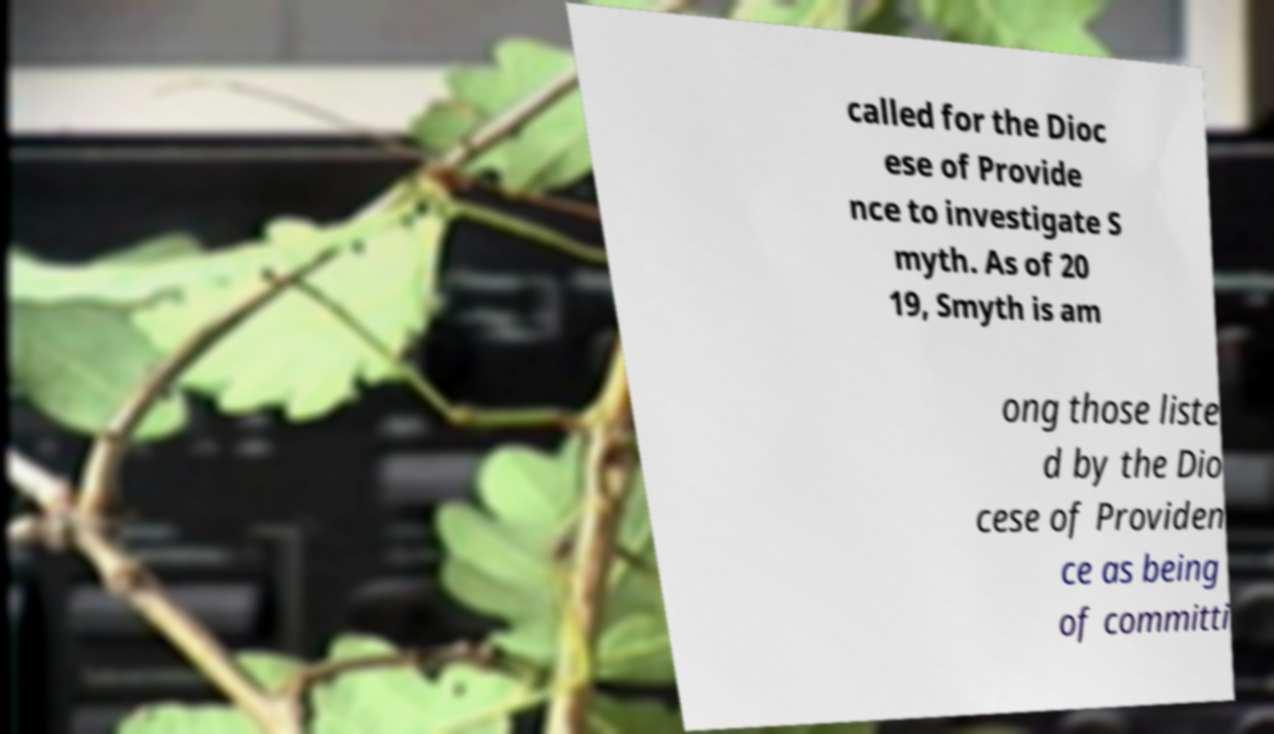Can you accurately transcribe the text from the provided image for me? called for the Dioc ese of Provide nce to investigate S myth. As of 20 19, Smyth is am ong those liste d by the Dio cese of Providen ce as being of committi 